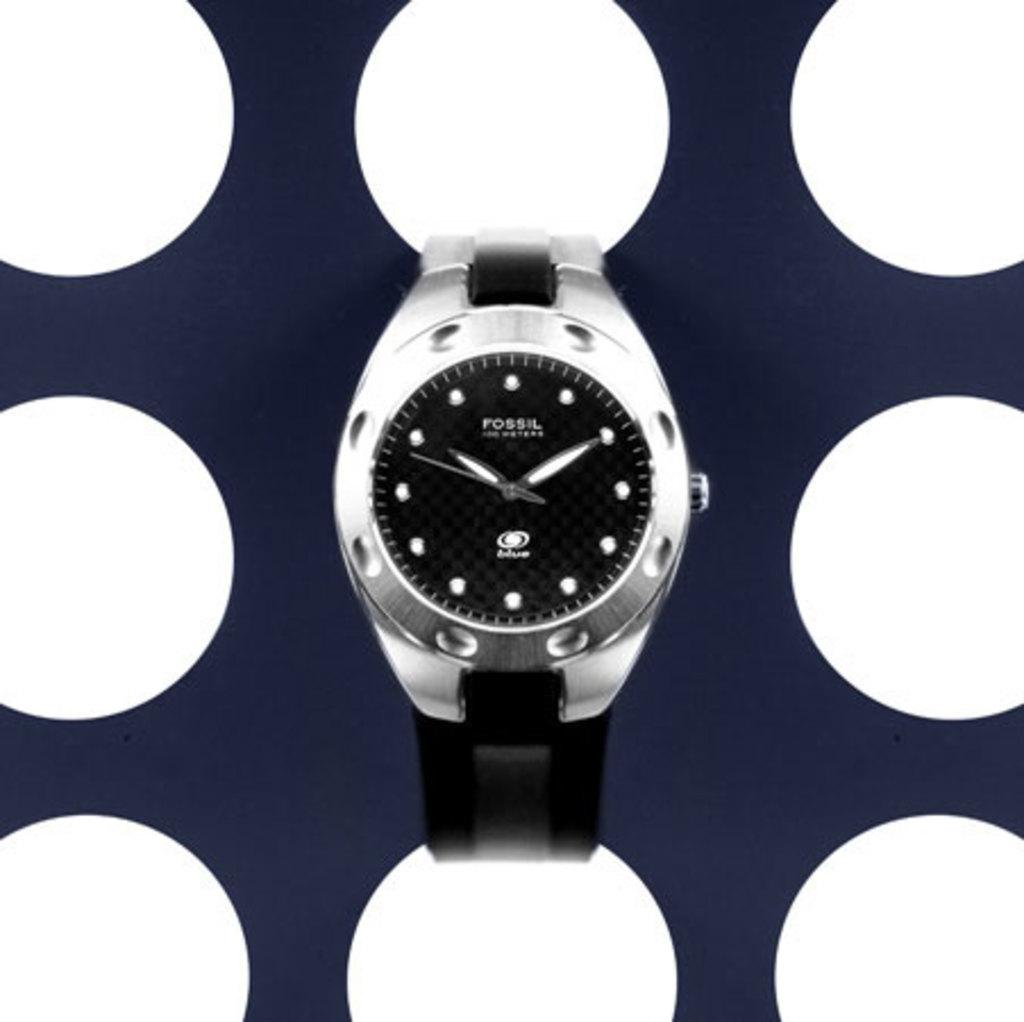Provide a one-sentence caption for the provided image. A Fossil watch with black bands and a modern style. 